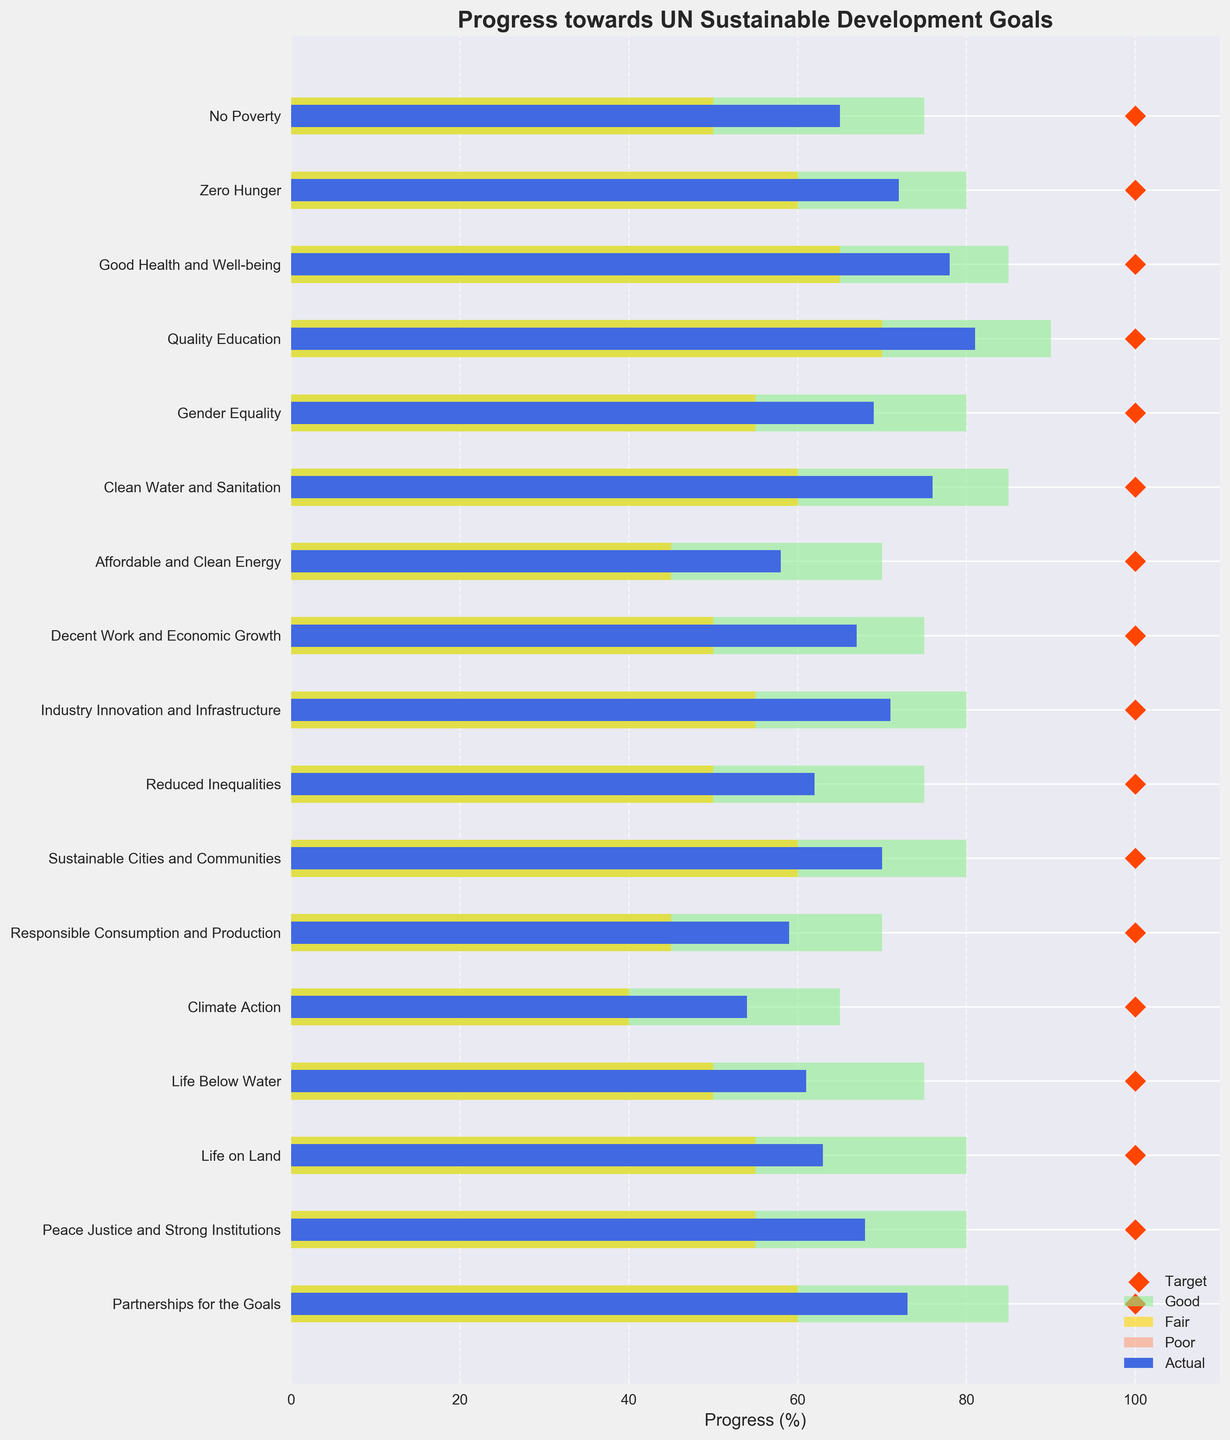What is the title of the chart? The title of the chart is displayed at the top and reads "Progress towards UN Sustainable Development Goals."
Answer: Progress towards UN Sustainable Development Goals What is the x-axis label of the chart? The x-axis label can be found at the bottom of the chart, and it is "Progress (%)".
Answer: Progress (%) Which goal category has the highest actual progress? By comparing the blue bars (actual progress) for all categories, "Quality Education" has the highest actual progress at 81%.
Answer: Quality Education Which goal category has the lowest actual progress? The blue bar for "Climate Action" is the shortest among all goals, indicating the lowest actual progress at 54%.
Answer: Climate Action How many categories have an actual progress value of 70% or more? Checking the blue bars (actual progress), the categories "Zero Hunger," "Good Health and Well-being," "Quality Education," "Gender Equality," "Clean Water and Sanitation," "Sustainable Cities and Communities," and "Partnerships for the Goals" have actual progress values of 70% or more. Thus, there are 7 categories.
Answer: 7 What is the actual progress for "Reduced Inequalities"? The blue bar for "Reduced Inequalities" has a value of 62%.
Answer: 62% Which categories fall into the "Good" range of progress? Comparing the rightmost edges of the green bars (Good range) with the actual progress (blue bars), the categories "No Poverty," "Zero Hunger," "Good Health and Well-being," "Quality Education," "Gender Equality," "Clean Water and Sanitation," and "Partnerships for the Goals" fall into the "Good" range.
Answer: No Poverty, Zero Hunger, Good Health and Well-being, Quality Education, Gender Equality, Clean Water and Sanitation, Partnerships for the Goals Are there any categories where the actual progress exceeds the "Fair" range but falls short of the "Good" range? The green bars (Good range) define the upper limits. Checking the actual progress (blue bars) against these, no category falls between the upper limit of the "Fair" range and the beginning of the "Good" range.
Answer: No Which category has the largest gap between the actual progress and the target? The difference between the actual progress (blue bar) and the target (red diamond) can be calculated. "Climate Action" has a target of 100% and actual progress of 54%, resulting in the largest gap of 46%.
Answer: Climate Action What is the target progress value for "Peace Justice and Strong Institutions"? The red diamond marker indicates that the target for "Peace Justice and Strong Institutions" is 100%.
Answer: 100% 